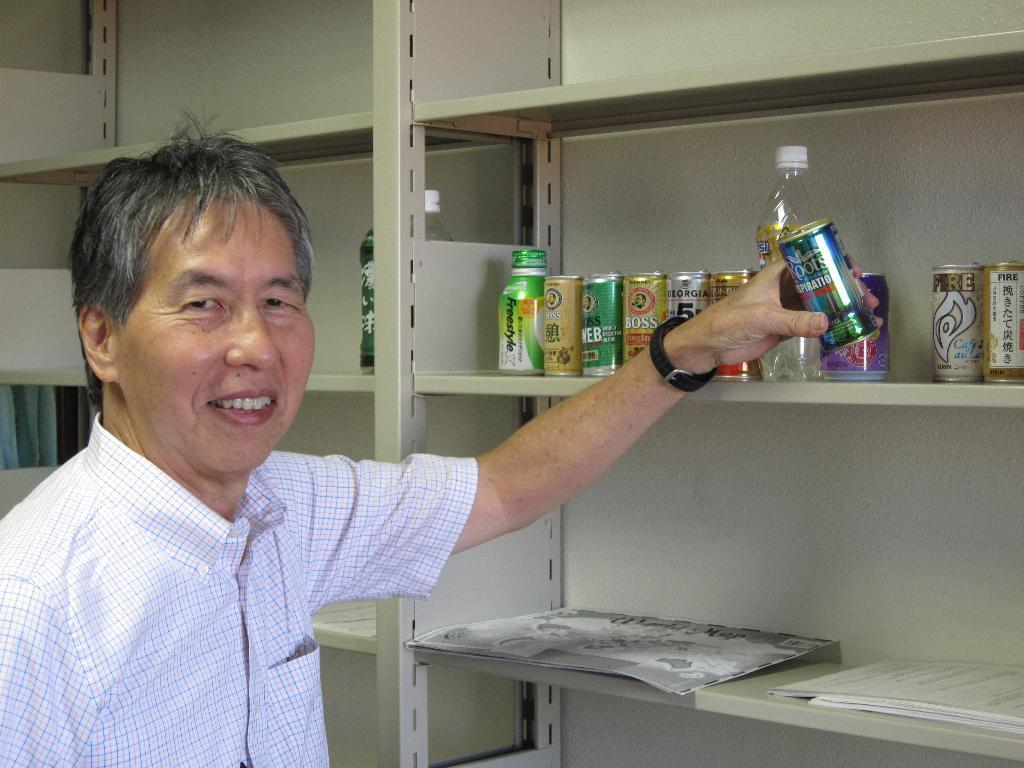What is the person holding in the image? The person is holding a tin in the image. How many tins can be seen in the image? There are multiple tins in the image. What other items are visible in the image? There are bottles in the image. What type of storage can be seen in the image? There are books in the shelves in the image. Where is the lunchroom located in the image? There is no mention of a lunchroom in the image. 